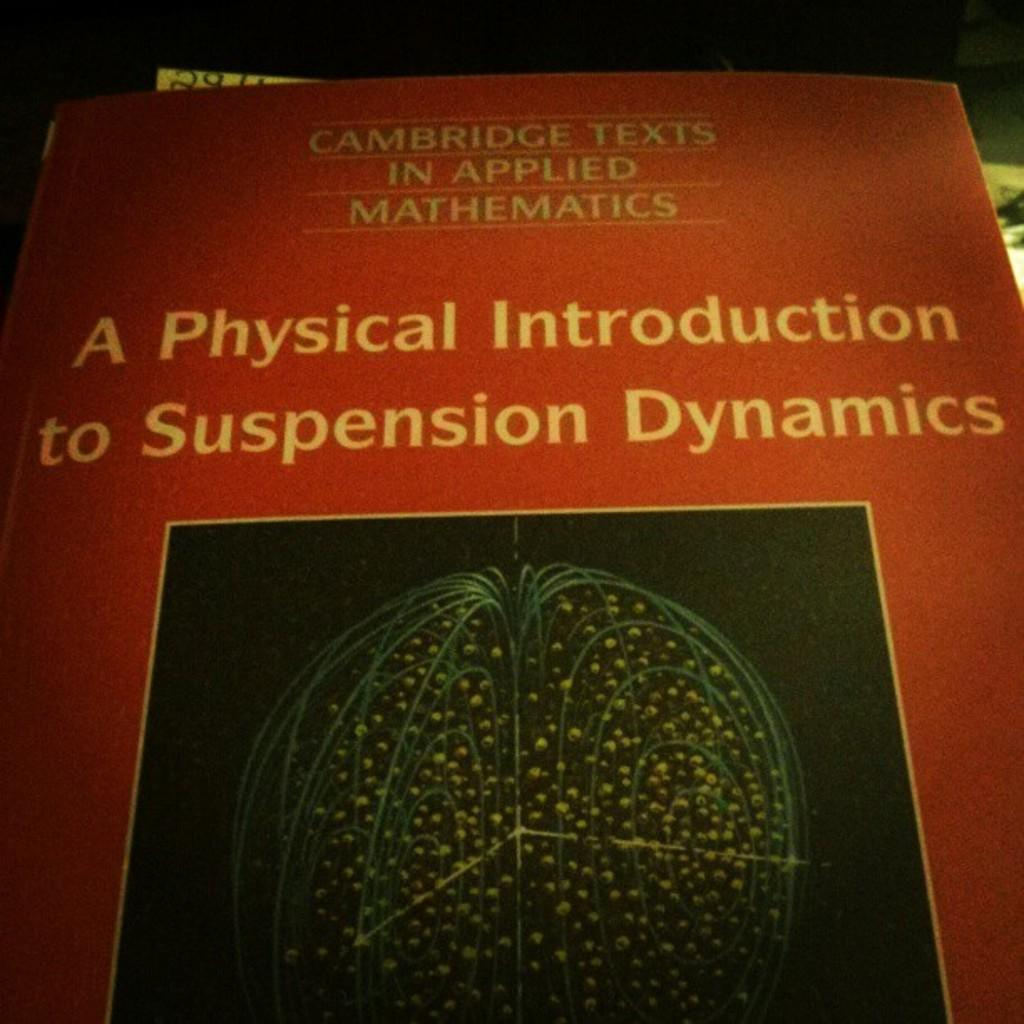<image>
Give a short and clear explanation of the subsequent image. A textbook by Cambridge Texts is about suspension dynamics. 